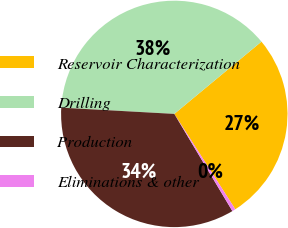Convert chart. <chart><loc_0><loc_0><loc_500><loc_500><pie_chart><fcel>Reservoir Characterization<fcel>Drilling<fcel>Production<fcel>Eliminations & other<nl><fcel>26.96%<fcel>38.1%<fcel>34.45%<fcel>0.48%<nl></chart> 